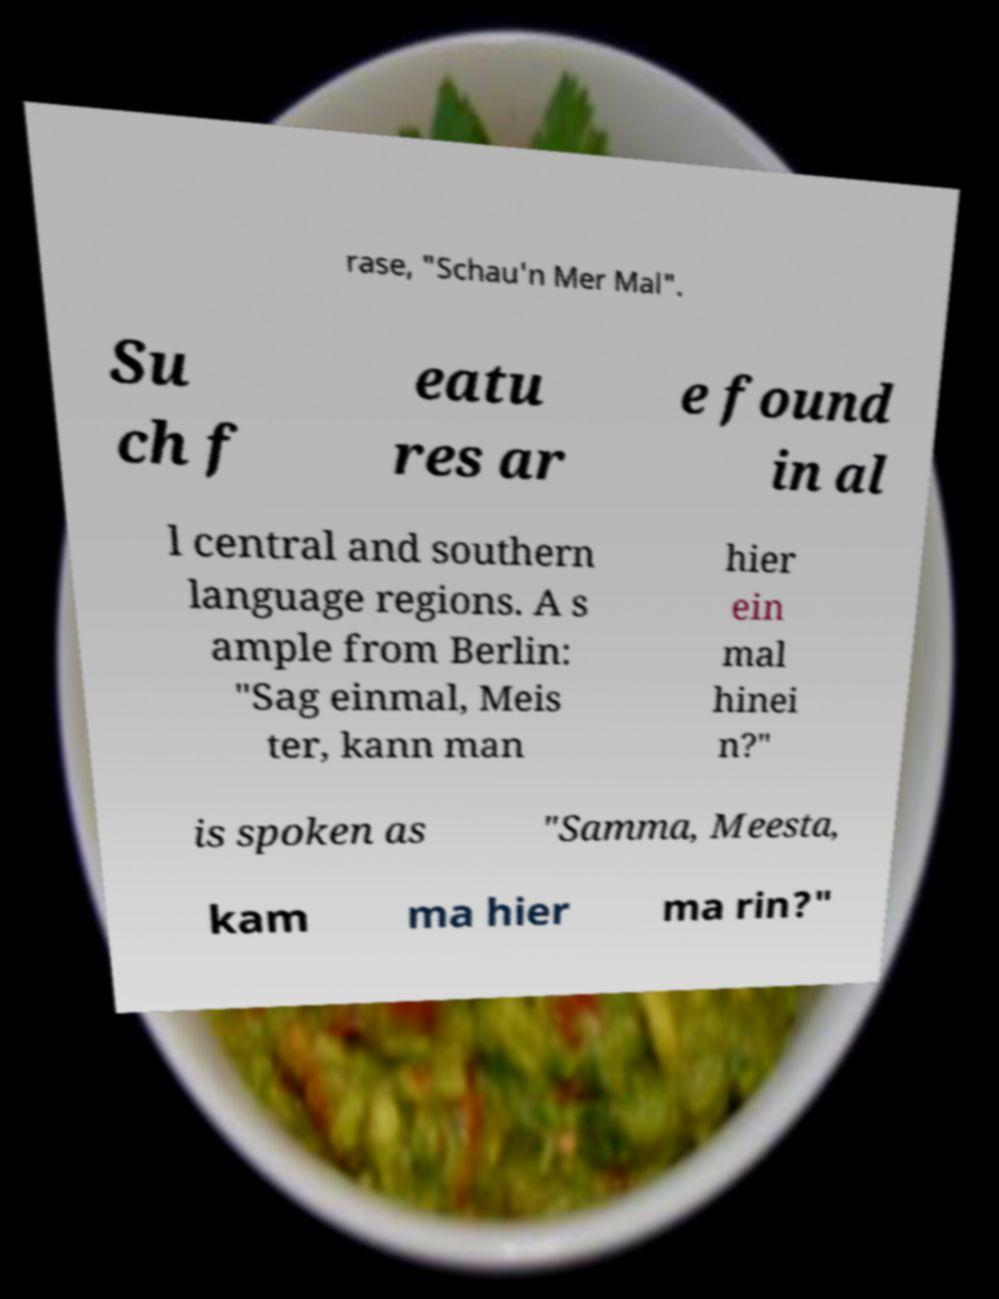Can you read and provide the text displayed in the image?This photo seems to have some interesting text. Can you extract and type it out for me? rase, "Schau'n Mer Mal". Su ch f eatu res ar e found in al l central and southern language regions. A s ample from Berlin: "Sag einmal, Meis ter, kann man hier ein mal hinei n?" is spoken as "Samma, Meesta, kam ma hier ma rin?" 